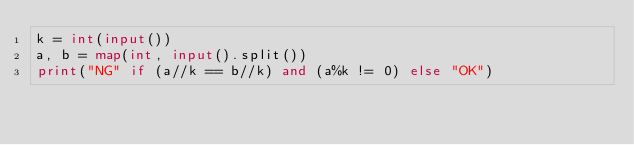Convert code to text. <code><loc_0><loc_0><loc_500><loc_500><_Python_>k = int(input())
a, b = map(int, input().split())
print("NG" if (a//k == b//k) and (a%k != 0) else "OK")</code> 